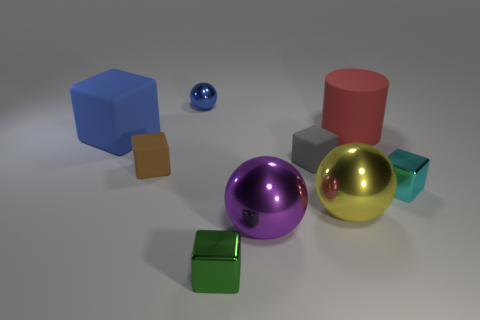Subtract all yellow shiny spheres. How many spheres are left? 2 Subtract all blue cubes. How many cubes are left? 4 Subtract all cylinders. How many objects are left? 8 Subtract 1 spheres. How many spheres are left? 2 Add 2 purple spheres. How many purple spheres are left? 3 Add 7 small cyan spheres. How many small cyan spheres exist? 7 Add 1 purple metallic spheres. How many objects exist? 10 Subtract 1 red cylinders. How many objects are left? 8 Subtract all yellow cubes. Subtract all blue spheres. How many cubes are left? 5 Subtract all green cubes. How many green balls are left? 0 